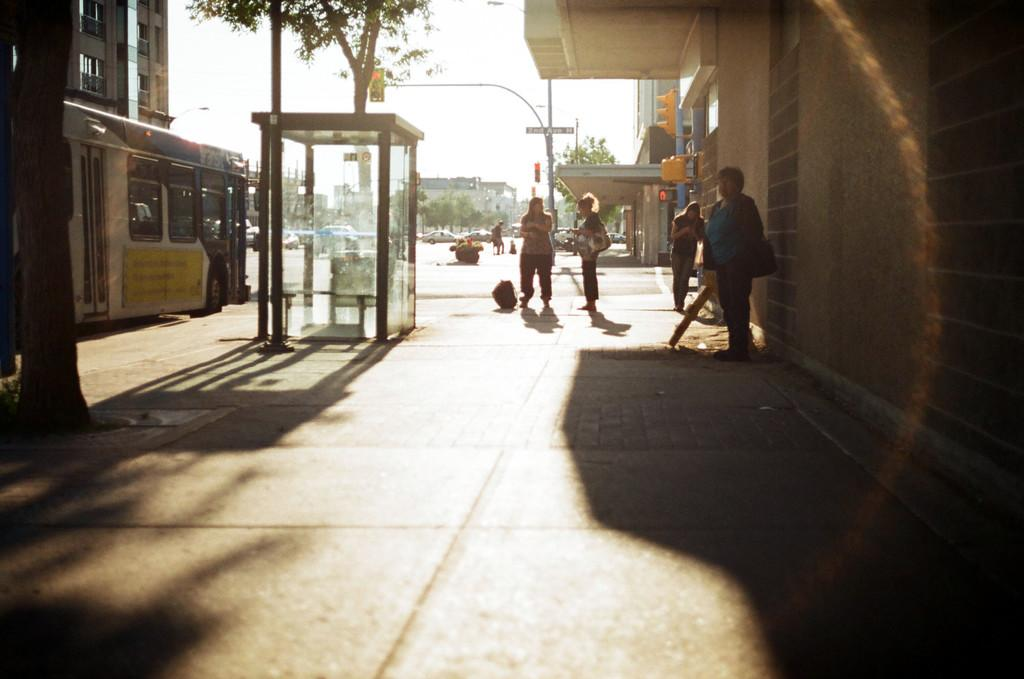What can be seen on the roads in the image? There are vehicles on the roads in the image. What type of natural elements are visible in the image? There are trees visible in the image. What type of architectural structures are present in the image? There are glass rooms and buildings in the image. What can be seen in front of the buildings in the image? There are people in front of the buildings in the image. What type of trade is being conducted on the sidewalk in the image? There is no sidewalk or trade present in the image. How many trains can be seen in the image? There are no trains visible in the image. 